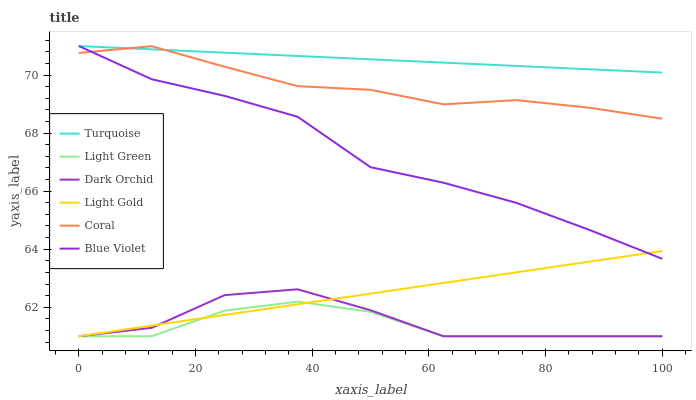Does Light Green have the minimum area under the curve?
Answer yes or no. Yes. Does Turquoise have the maximum area under the curve?
Answer yes or no. Yes. Does Coral have the minimum area under the curve?
Answer yes or no. No. Does Coral have the maximum area under the curve?
Answer yes or no. No. Is Light Gold the smoothest?
Answer yes or no. Yes. Is Dark Orchid the roughest?
Answer yes or no. Yes. Is Coral the smoothest?
Answer yes or no. No. Is Coral the roughest?
Answer yes or no. No. Does Dark Orchid have the lowest value?
Answer yes or no. Yes. Does Coral have the lowest value?
Answer yes or no. No. Does Blue Violet have the highest value?
Answer yes or no. Yes. Does Coral have the highest value?
Answer yes or no. No. Is Light Green less than Blue Violet?
Answer yes or no. Yes. Is Turquoise greater than Light Gold?
Answer yes or no. Yes. Does Dark Orchid intersect Light Green?
Answer yes or no. Yes. Is Dark Orchid less than Light Green?
Answer yes or no. No. Is Dark Orchid greater than Light Green?
Answer yes or no. No. Does Light Green intersect Blue Violet?
Answer yes or no. No. 